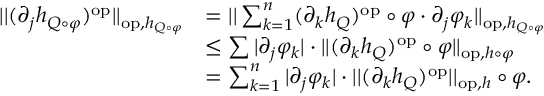Convert formula to latex. <formula><loc_0><loc_0><loc_500><loc_500>\begin{array} { r l } { | | ( \partial _ { j } h _ { Q \circ \varphi } ) ^ { o p } | | _ { o p , h _ { Q \circ \varphi } } } & { = | | \sum _ { k = 1 } ^ { n } ( \partial _ { k } h _ { Q } ) ^ { o p } \circ \varphi \cdot \partial _ { j } \varphi _ { k } | | _ { o p , h _ { Q \circ \varphi } } } \\ & { \leq \sum | \partial _ { j } \varphi _ { k } | \cdot | | ( \partial _ { k } h _ { Q } ) ^ { o p } \circ \varphi | | _ { o p , h \circ \varphi } } \\ & { = \sum _ { k = 1 } ^ { n } | \partial _ { j } \varphi _ { k } | \cdot | | ( \partial _ { k } h _ { Q } ) ^ { o p } | | _ { o p , h } \circ \varphi . } \end{array}</formula> 